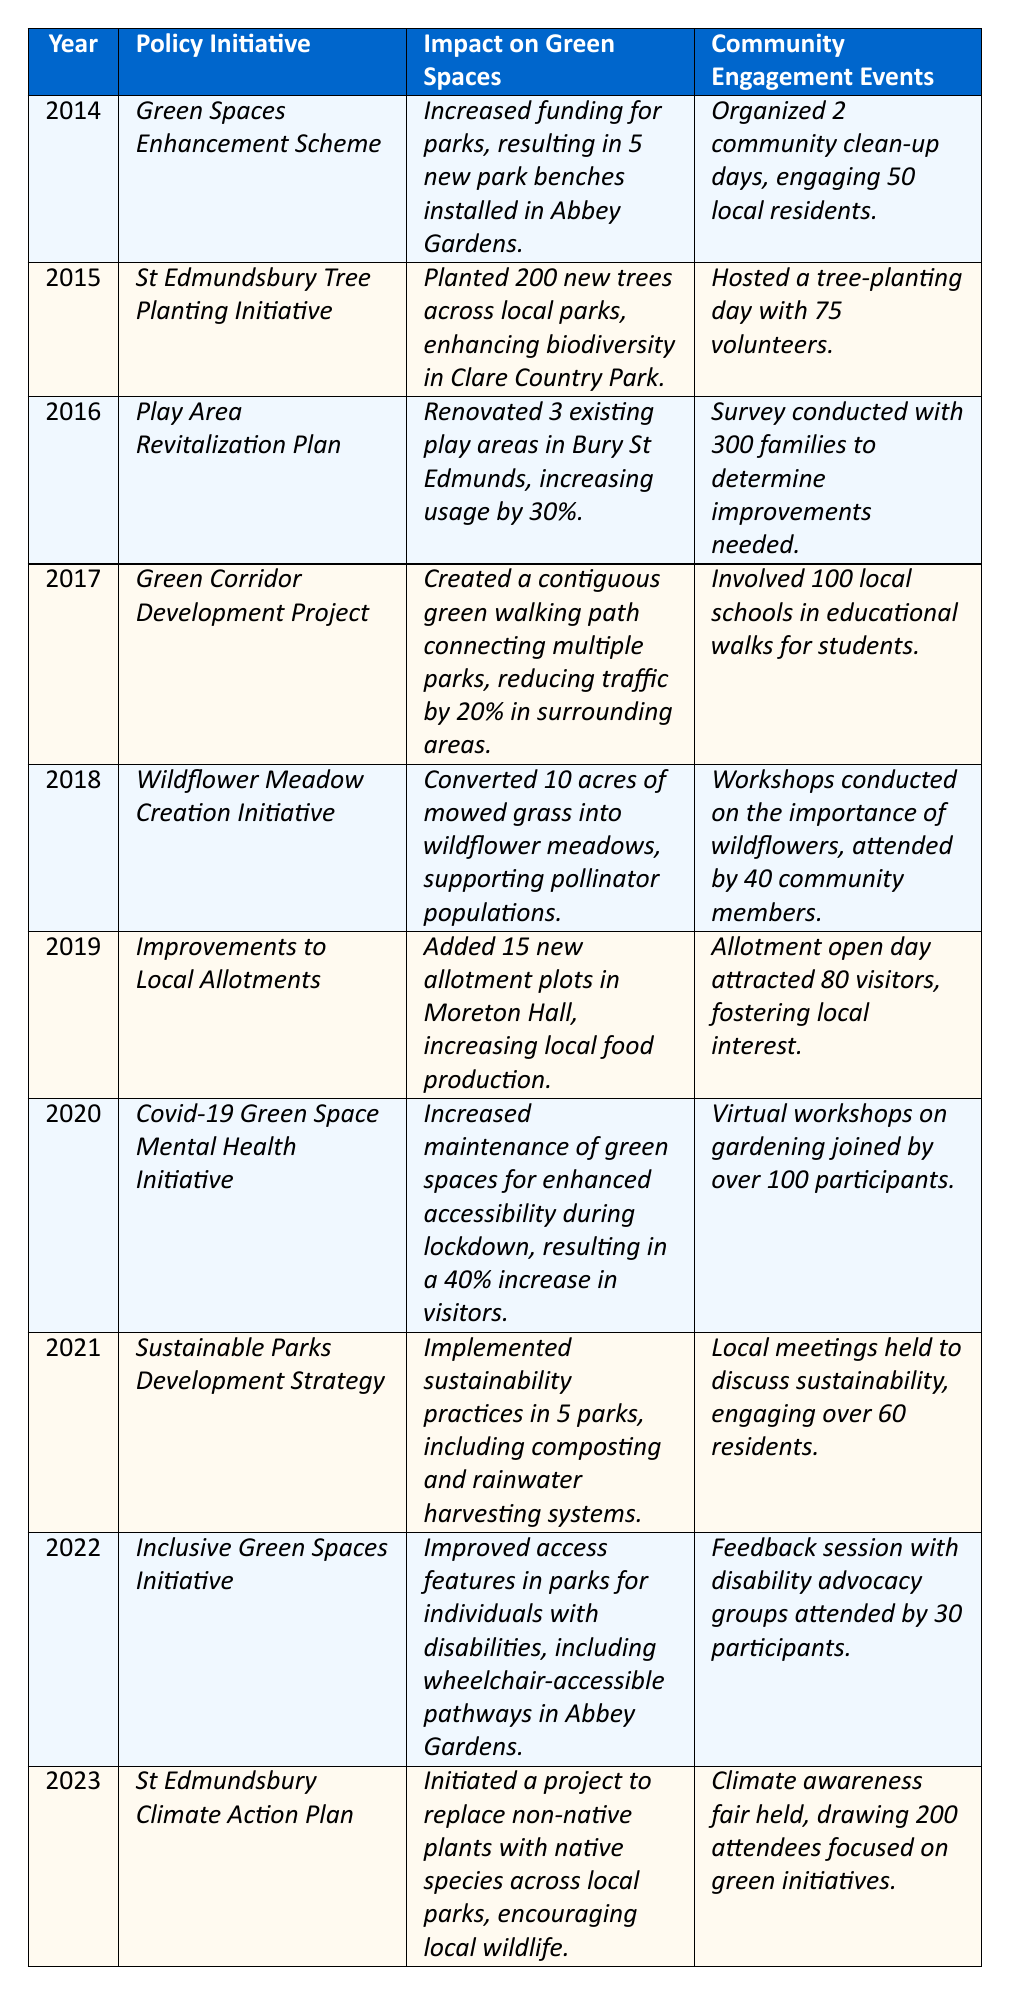What was the impact of the *Green Spaces Enhancement Scheme* in 2014? The table states that the impact of this initiative was an increase in funding for parks, which resulted in 5 new park benches installed in Abbey Gardens.
Answer: Increased funding and 5 new park benches How many trees were planted in 2015 through the *St Edmundsbury Tree Planting Initiative*? According to the table, this initiative resulted in the planting of 200 new trees across local parks.
Answer: 200 trees Which year saw a 40% increase in visitors due to a specific initiative? The *Covid-19 Green Space Mental Health Initiative* in 2020 resulted in a 40% increase in visitors due to improved maintenance and accessibility of green spaces.
Answer: 2020 saw a 40% increase Did the *Inclusive Green Spaces Initiative* focus on improving access for individuals with disabilities? Yes, it improved access features in parks for individuals with disabilities, specifically mentioning wheelchair-accessible pathways in Abbey Gardens.
Answer: Yes What was the total number of community engagement events held from 2014 to 2016? The events were: 2 (2014) + 1 (2015) + 1 (2016) = 4. Therefore, the total number is 4 community engagement events.
Answer: 4 events How many new allotment plots were added in 2019 due to improvements to local allotments? The table indicates that 15 new allotment plots were added in Moreton Hall that year.
Answer: 15 new allotment plots In which year was a contiguous green walking path created, and what percentage did it reduce traffic by? The *Green Corridor Development Project* in 2017 created a walking path that reduced traffic by 20% in surrounding areas.
Answer: 2017 and reduced traffic by 20% What was the average number of community engagement attendees for the years 2020 to 2023? The number of attendees were: 100 (2020) + 60 (2021) + 30 (2022) + 200 (2023) = 390. The average is 390/4 = 97.5.
Answer: 97.5 attendees Did the *Wildflower Meadow Creation Initiative* include community workshops, and if so, how many attendees were present? Yes, it included workshops on the importance of wildflowers, attended by 40 community members.
Answer: Yes, 40 attendees Which initiative had the highest community engagement in terms of attendance and how many attended? The *St Edmundsbury Climate Action Plan* had the highest attendance with 200 attendees at the climate awareness fair.
Answer: *St Edmundsbury Climate Action Plan* with 200 attendees 